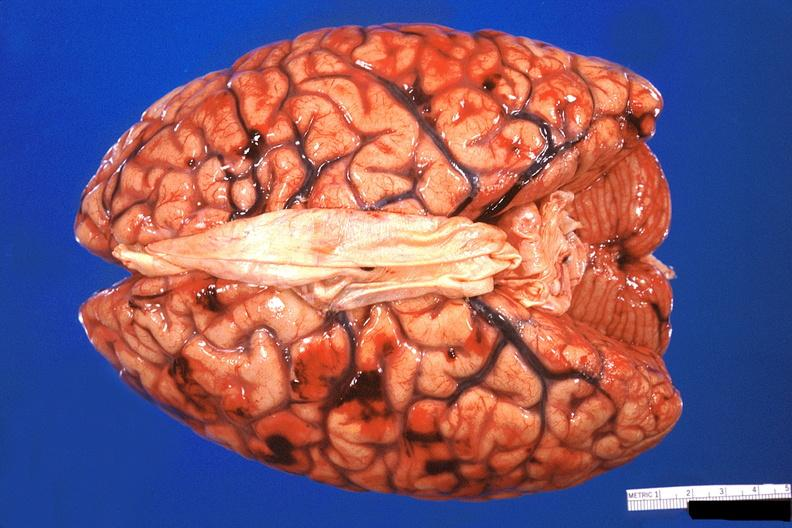does muscle show brain, subarachanoid hemorrhage due to disseminated intravascular coagulation?
Answer the question using a single word or phrase. No 